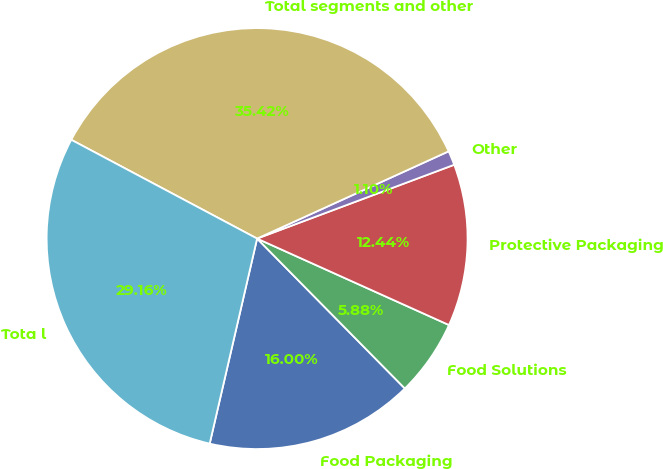Convert chart. <chart><loc_0><loc_0><loc_500><loc_500><pie_chart><fcel>Food Packaging<fcel>Food Solutions<fcel>Protective Packaging<fcel>Other<fcel>Total segments and other<fcel>Tota l<nl><fcel>16.0%<fcel>5.88%<fcel>12.44%<fcel>1.1%<fcel>35.42%<fcel>29.16%<nl></chart> 